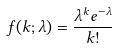Convert formula to latex. <formula><loc_0><loc_0><loc_500><loc_500>f ( k ; \lambda ) = \frac { \lambda ^ { k } e ^ { - \lambda } } { k ! }</formula> 